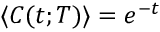Convert formula to latex. <formula><loc_0><loc_0><loc_500><loc_500>\langle C ( t ; T ) \rangle = e ^ { - t }</formula> 